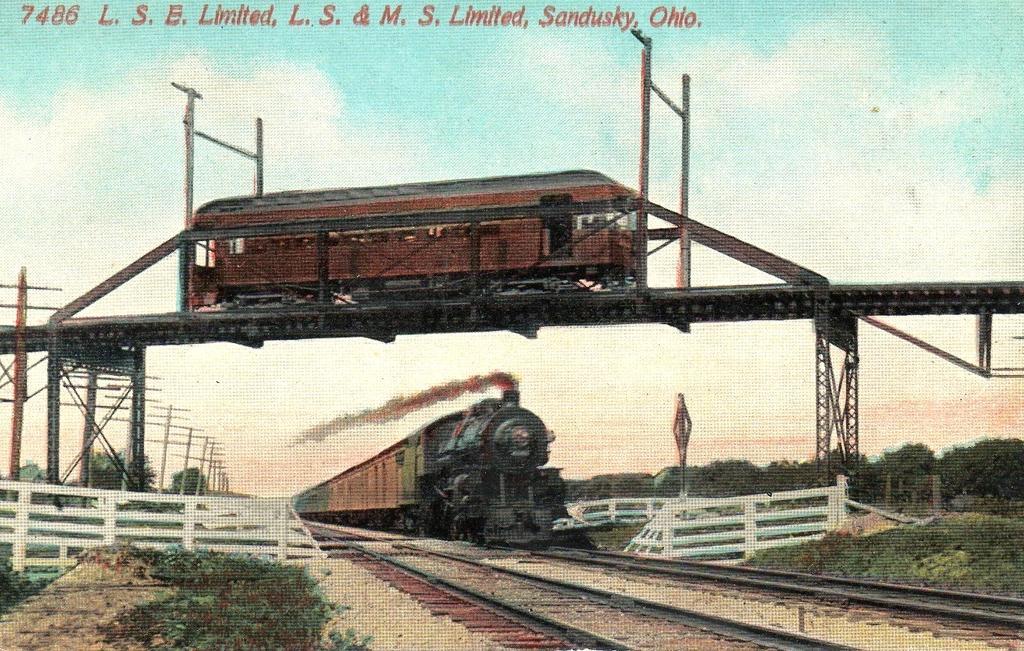Can you describe this image briefly? In this image there is a train on the railway track. There is a wooden fence. On both right and left side of the image there is grass on the surface. In the center of the image there is a train on the bridge. In the background of the image there are trees, poles and sky. There is some text at the top of the image. 